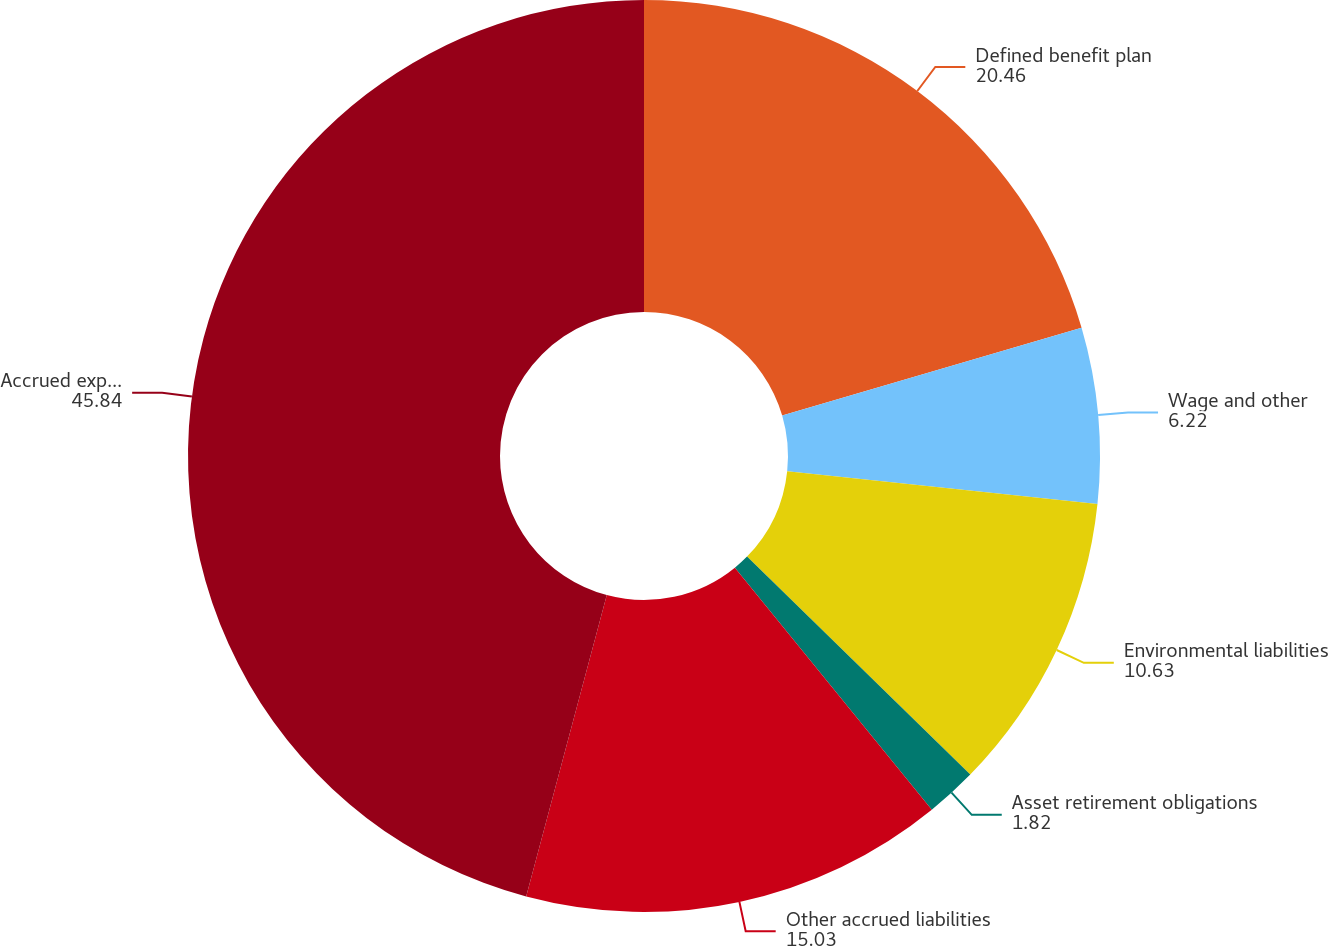<chart> <loc_0><loc_0><loc_500><loc_500><pie_chart><fcel>Defined benefit plan<fcel>Wage and other<fcel>Environmental liabilities<fcel>Asset retirement obligations<fcel>Other accrued liabilities<fcel>Accrued expenses and other<nl><fcel>20.46%<fcel>6.22%<fcel>10.63%<fcel>1.82%<fcel>15.03%<fcel>45.84%<nl></chart> 